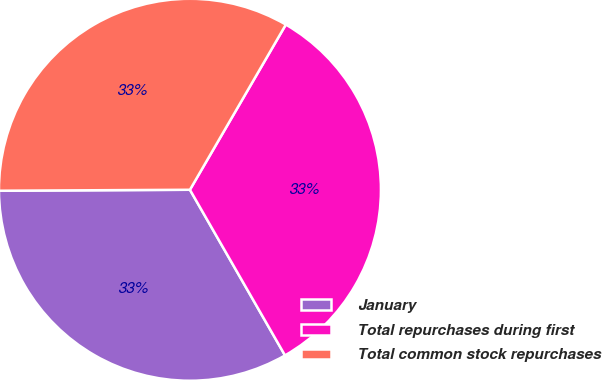<chart> <loc_0><loc_0><loc_500><loc_500><pie_chart><fcel>January<fcel>Total repurchases during first<fcel>Total common stock repurchases<nl><fcel>33.21%<fcel>33.33%<fcel>33.45%<nl></chart> 